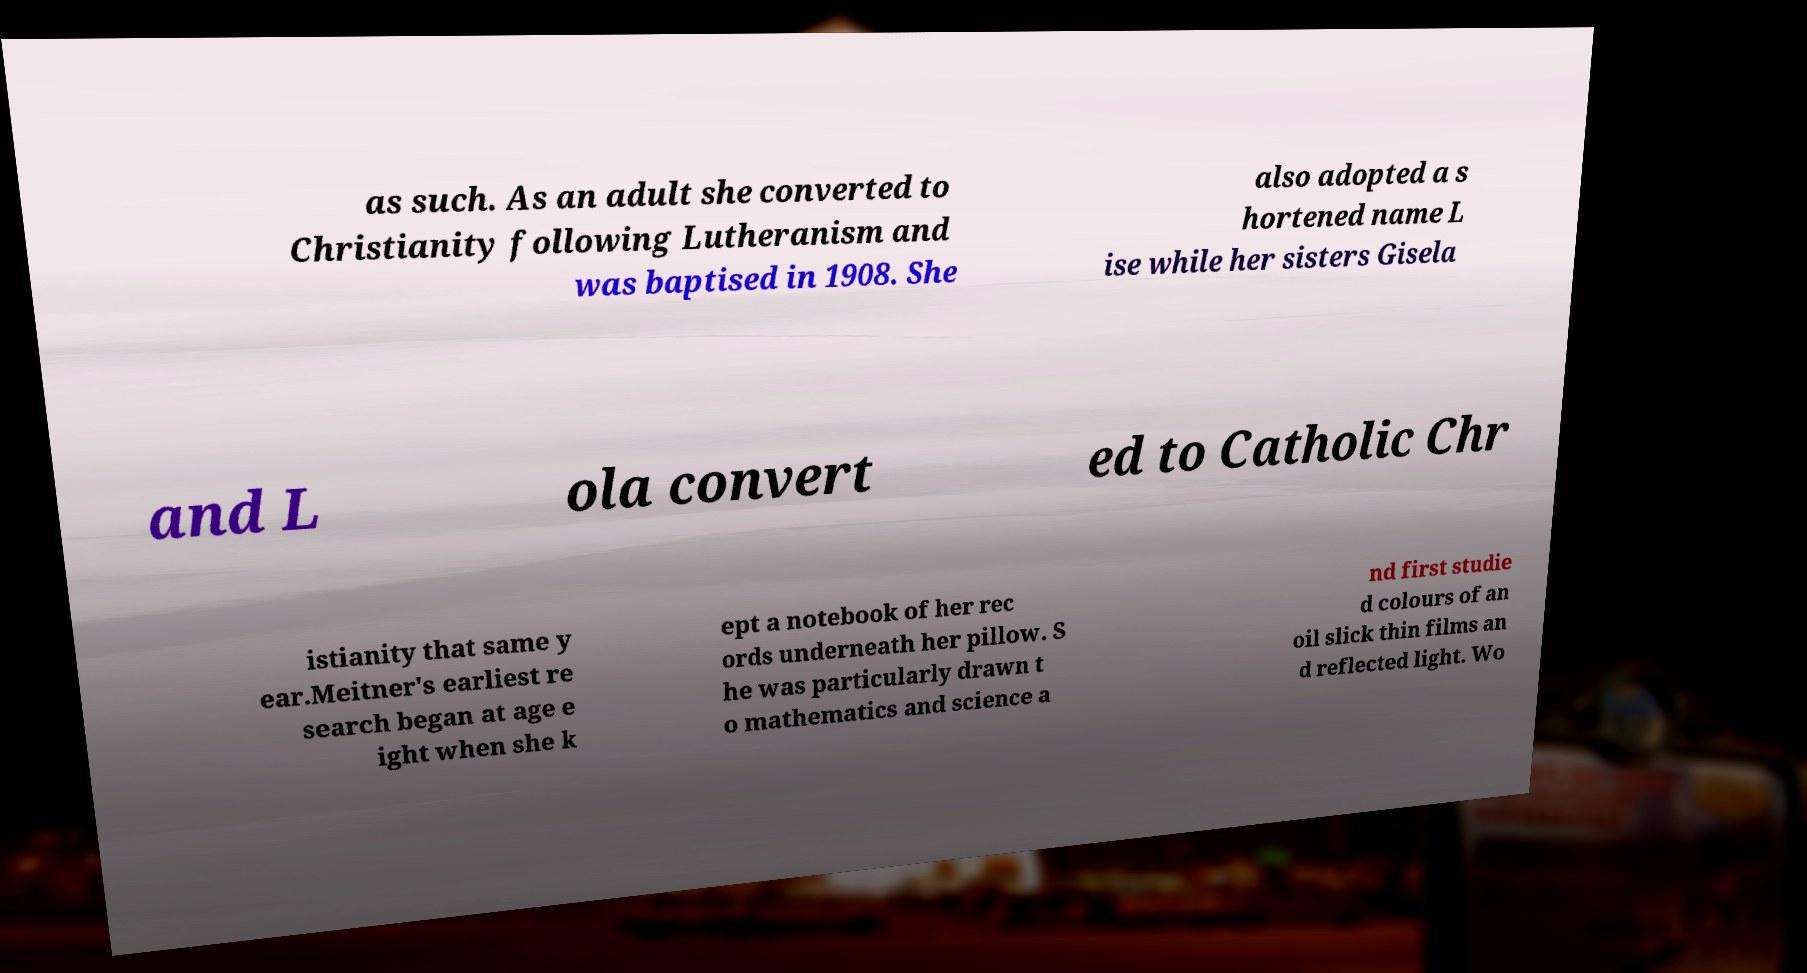Could you extract and type out the text from this image? as such. As an adult she converted to Christianity following Lutheranism and was baptised in 1908. She also adopted a s hortened name L ise while her sisters Gisela and L ola convert ed to Catholic Chr istianity that same y ear.Meitner's earliest re search began at age e ight when she k ept a notebook of her rec ords underneath her pillow. S he was particularly drawn t o mathematics and science a nd first studie d colours of an oil slick thin films an d reflected light. Wo 